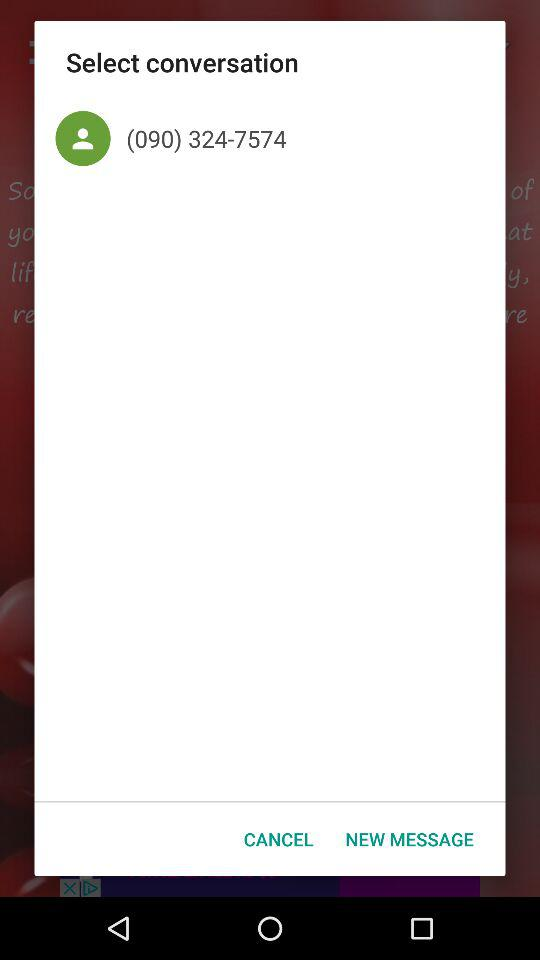What is the mentioned contact number? The mentioned contact number is (090) 324-7574. 